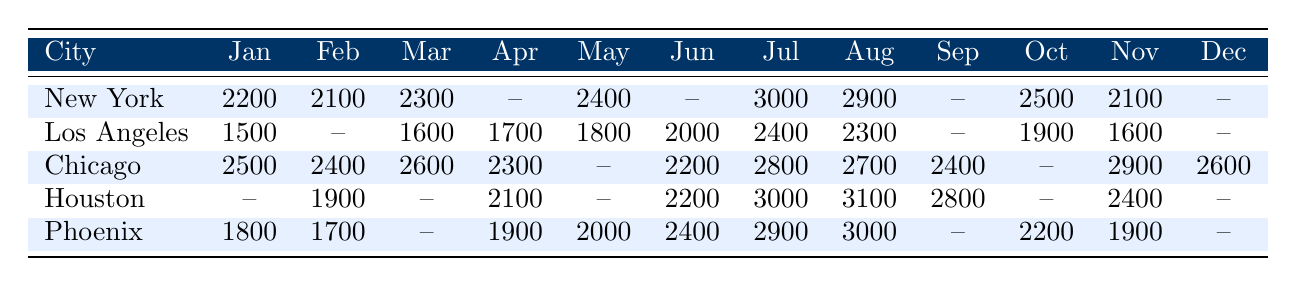What is the energy consumption of New York in June? In the table, it shows that the energy consumption of New York in June is marked as null, which means no data is available for that month.
Answer: No data available In which month did Chicago have the highest energy consumption? Looking at the values for Chicago, the highest energy consumption was in July with 2800 units.
Answer: July What is the average energy consumption for Los Angeles from January to July? The values for Los Angeles in January (1500), March (1600), April (1700), May (1800), June (2000), and July (2400) are added (1500 + 1600 + 1700 + 1800 + 2000 + 2400 = 11000). Then, we divide by the number of months with data (6), resulting in an average of 1833.33.
Answer: 1833.33 Was there any month in 2022 where Houston had no energy consumption recorded? Examining the table for Houston, months of January, March, May, October, and December have no recorded values (marked as null). Hence, the answer is yes.
Answer: Yes What was the total energy consumption by Phoenix from January to December, excluding months with no data? For Phoenix, the available values are: January (1800), February (1700), April (1900), May (2000), June (2400), July (2900), August (3000), September (null), October (2200), November (1900). Adding these yields 1800 + 1700 + 1900 + 2000 + 2400 + 2900 + 3000 + 2200 + 1900 = 19800; thus, the total consumption is 19800 units.
Answer: 19800 Which city had the highest energy consumption in July? Comparing the July energy consumption values: New York (3000), Los Angeles (2400), Chicago (2800), Houston (3000), Phoenix (2900), both New York and Houston recorded the highest at 3000 units.
Answer: New York and Houston What is the month with the lowest recorded energy consumption in Chicago? Looking through Chicago's data, May is the only month where the value is marked as null, hence it has no recorded consumption. However, the next lowest recorded month is April at 2300. Thus, April has the lowest recorded consumption that is not null.
Answer: April How does the energy consumption in Los Angeles compare in August and September? Reviewing the table, the energy consumption in August for Los Angeles is 2300 and in September, it is null. Thus, we can say that August had data available, while September did not.
Answer: August has consumption; September has no data 